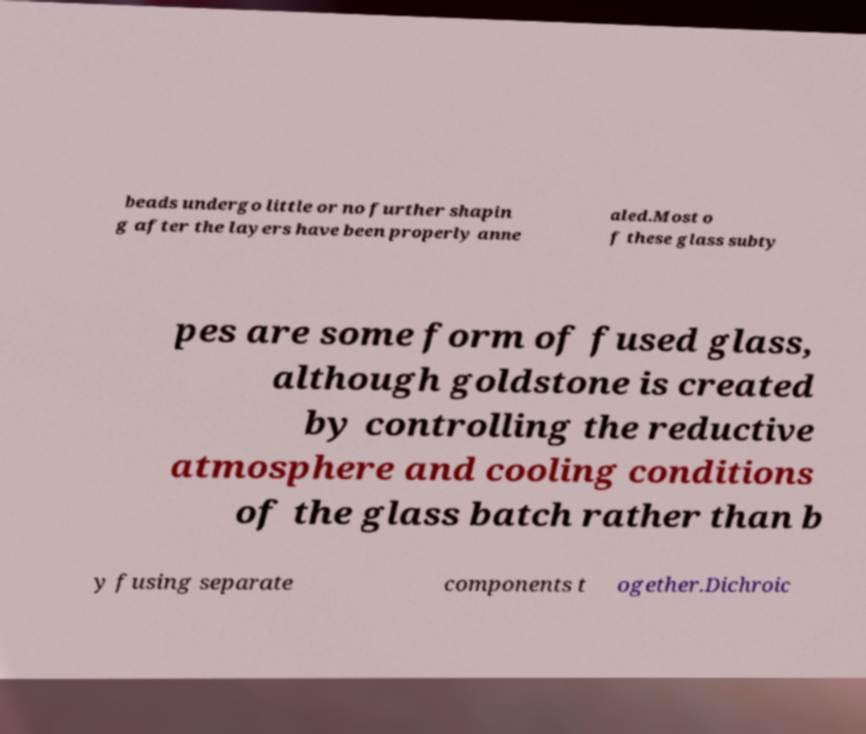Can you read and provide the text displayed in the image?This photo seems to have some interesting text. Can you extract and type it out for me? beads undergo little or no further shapin g after the layers have been properly anne aled.Most o f these glass subty pes are some form of fused glass, although goldstone is created by controlling the reductive atmosphere and cooling conditions of the glass batch rather than b y fusing separate components t ogether.Dichroic 